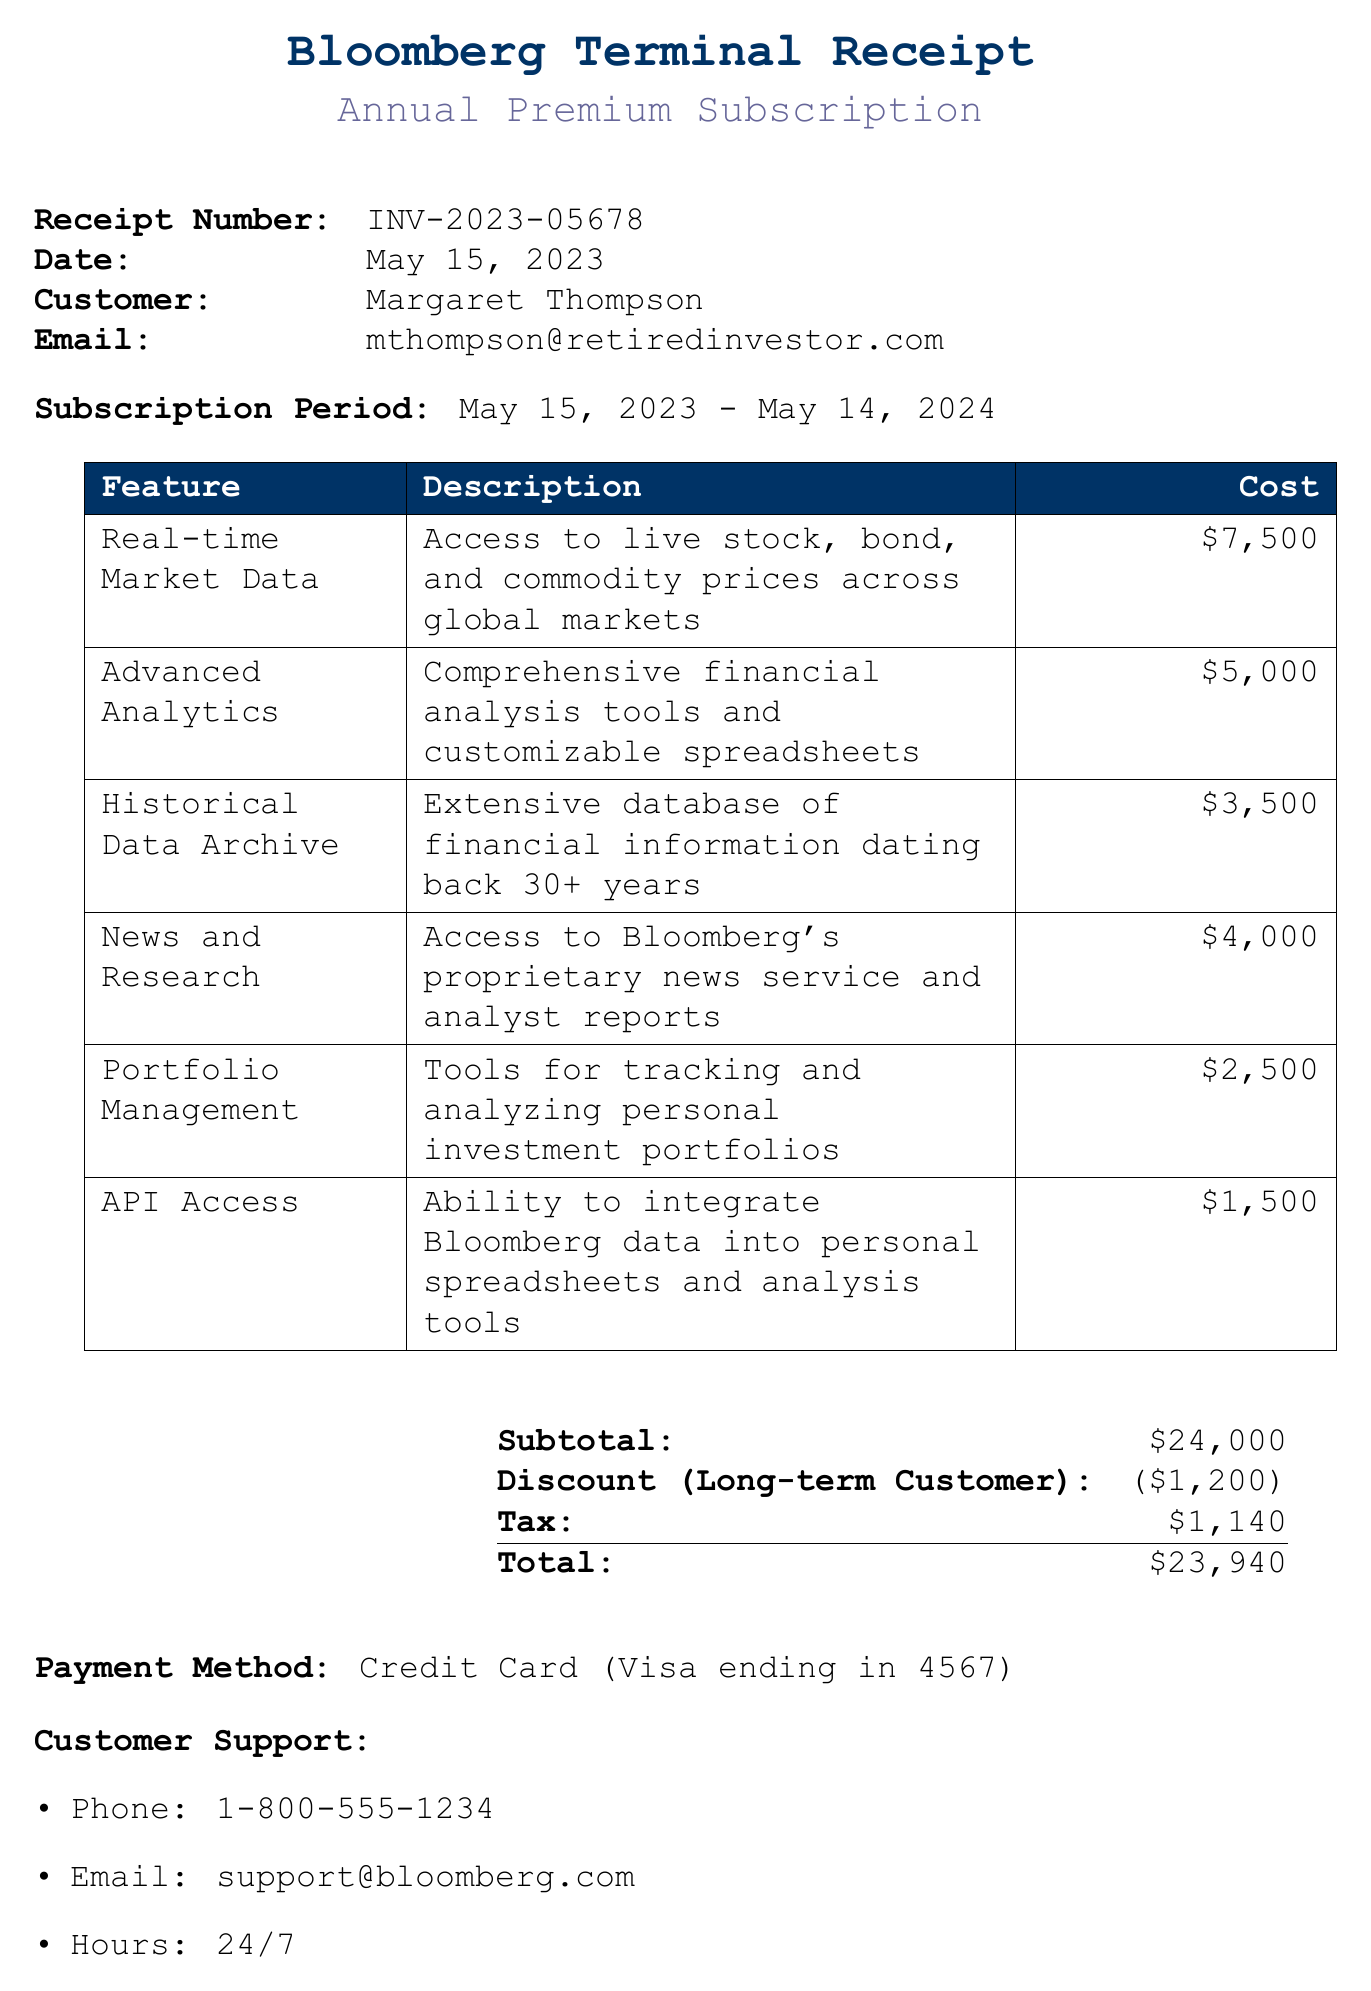What is the receipt number? The receipt number is indicated at the top of the receipt for easy reference.
Answer: INV-2023-05678 Who is the customer? The customer’s name appears alongside their email address on the receipt.
Answer: Margaret Thompson What is the subscription type? The receipt specifies the type of subscription purchased.
Answer: Annual Premium What is the total cost after discount? The total cost reflects the subtotal, discount, and tax calculated together.
Answer: $23,940 How many features are included in the subscription? The receipt lists all the features included in the subscription plan.
Answer: 6 What discount was applied? The receipt states the reason for the discount and the amount.
Answer: $1,200 What payment method was used? The payment method is detailed on the receipt.
Answer: Credit Card (Visa ending in 4567) What is the customer support email? The customer support email is provided for any inquiries or assistance.
Answer: support@bloomberg.com What is one additional feature included in the subscription? The additional notes section outlines benefits beyond basic features.
Answer: Access to exclusive webinars on advanced financial analysis techniques 